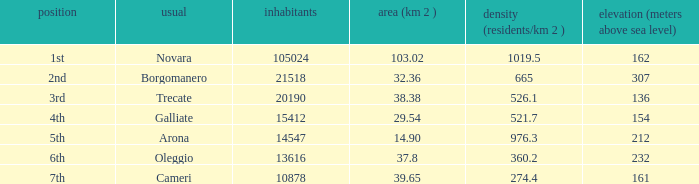Where does the galliate common rank in terms of population? 4th. 